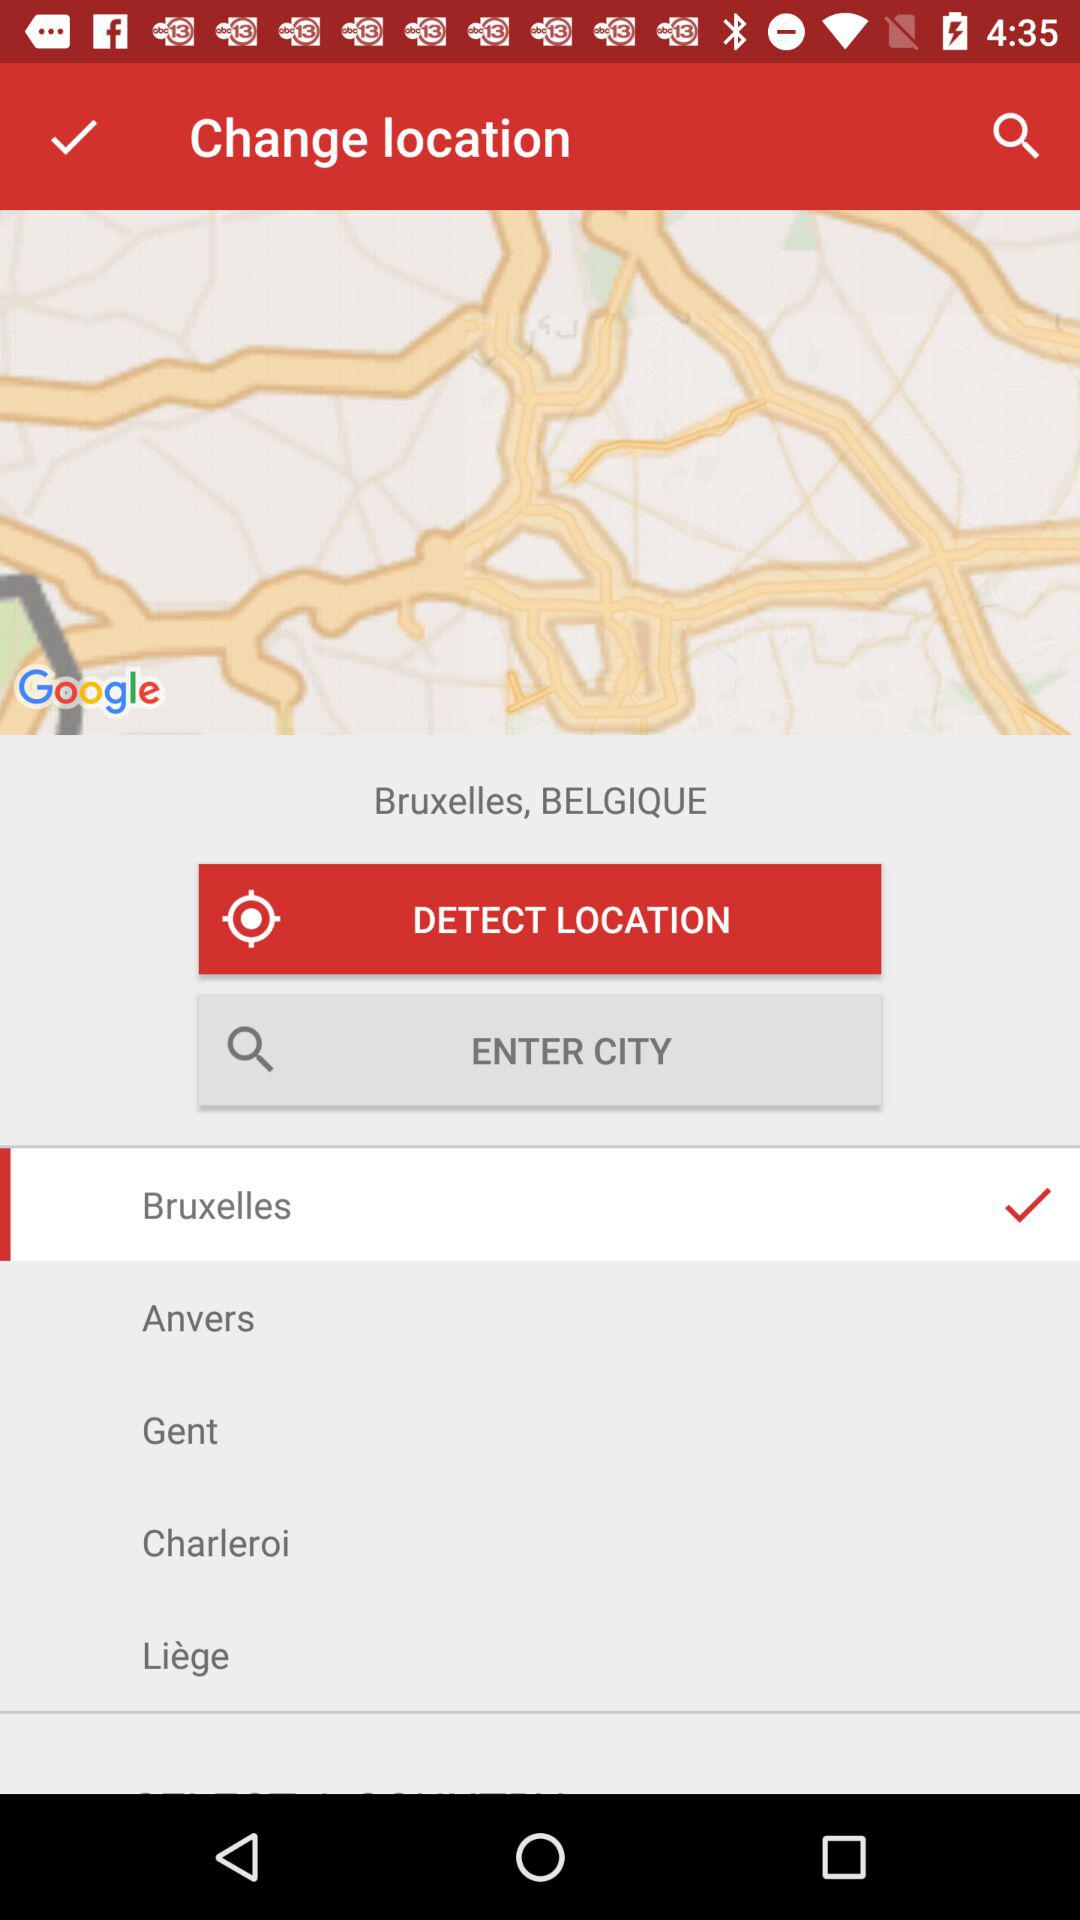What is the selected location? The selected location is Bruxelles. 